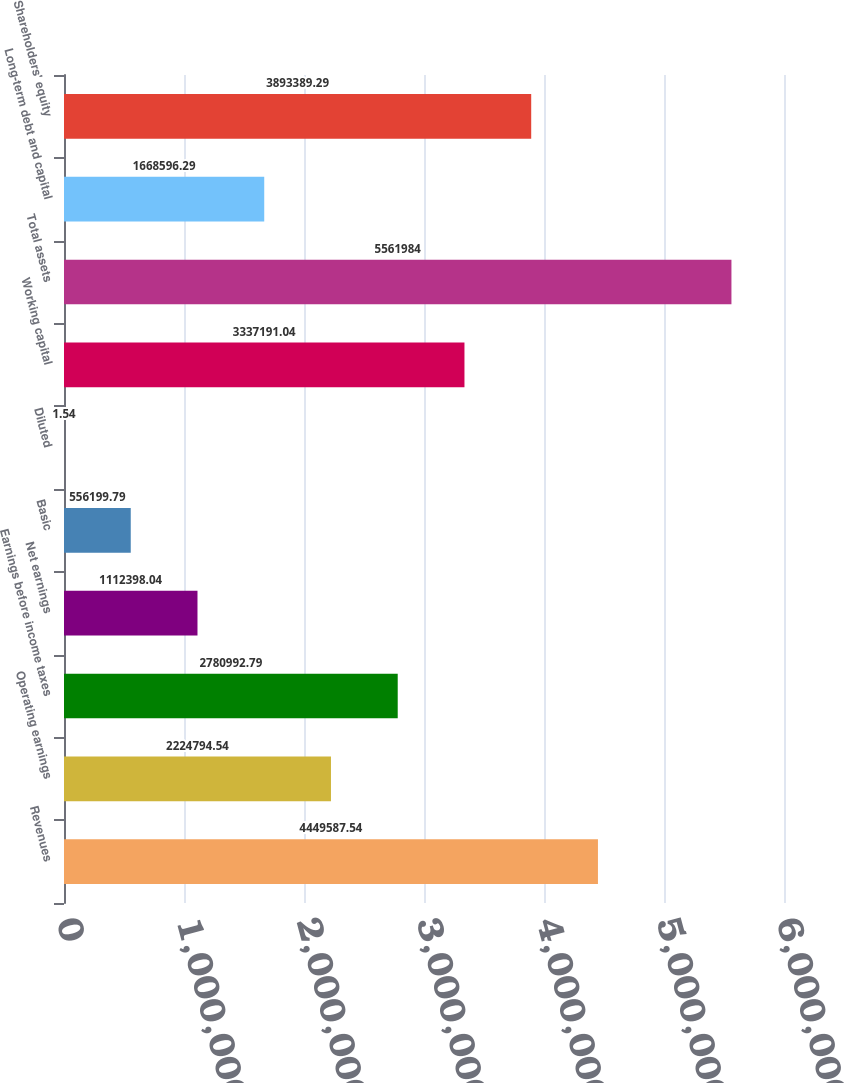Convert chart. <chart><loc_0><loc_0><loc_500><loc_500><bar_chart><fcel>Revenues<fcel>Operating earnings<fcel>Earnings before income taxes<fcel>Net earnings<fcel>Basic<fcel>Diluted<fcel>Working capital<fcel>Total assets<fcel>Long-term debt and capital<fcel>Shareholders' equity<nl><fcel>4.44959e+06<fcel>2.22479e+06<fcel>2.78099e+06<fcel>1.1124e+06<fcel>556200<fcel>1.54<fcel>3.33719e+06<fcel>5.56198e+06<fcel>1.6686e+06<fcel>3.89339e+06<nl></chart> 